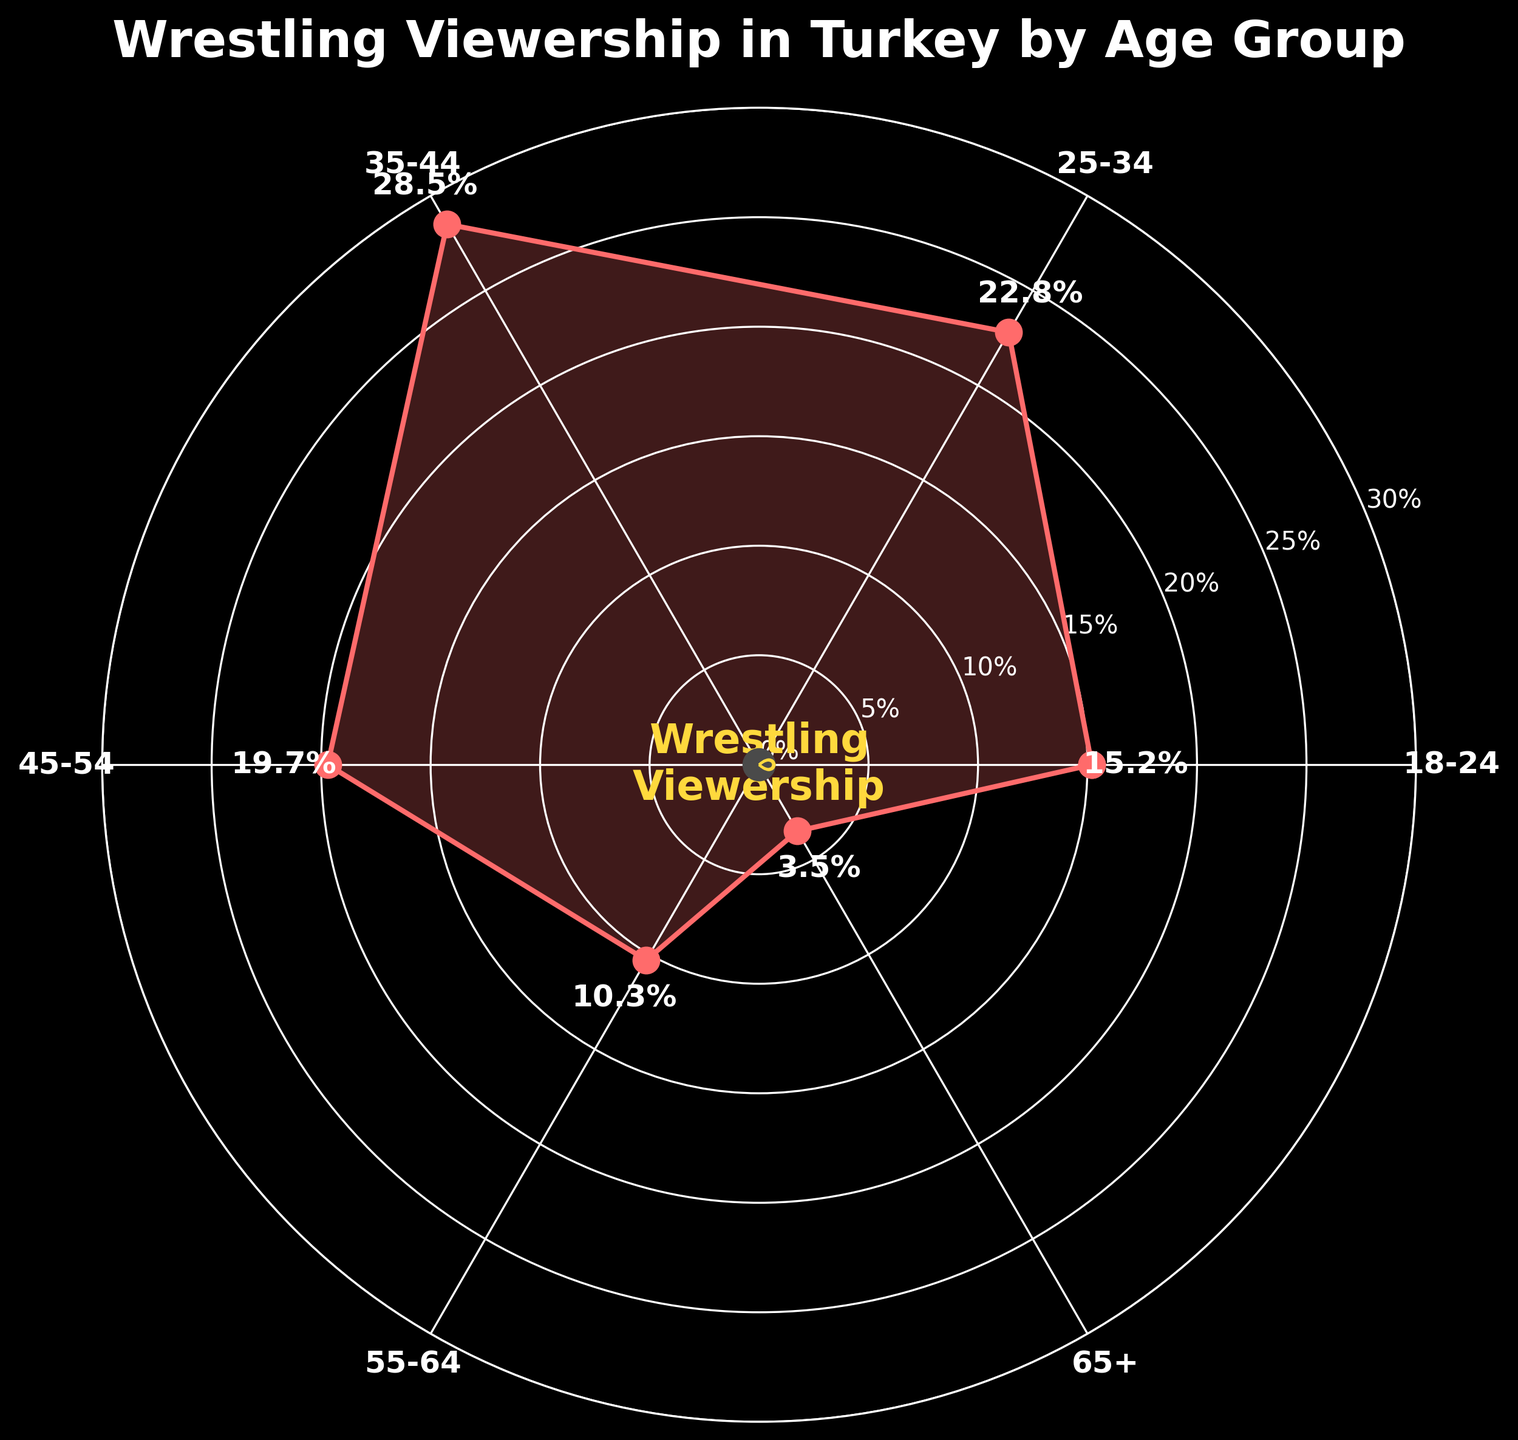What is the highest percentage of Turkish citizens who regularly watch wrestling? The highest percentage can be seen at the topmost data point on the plot, which aligns with the age group 35-44. The value indicated next to the point is 28.5%
Answer: 28.5% Which age group has the lowest percentage of viewers? The lowest percentage is at the smallest data point on the plot, which aligns with the age group 65+. The value indicated next to the point is 3.5%
Answer: 3.5% What is the percentage of viewers in the age group 18-24? To find the percentage of viewers in the age group 18-24, look at the position on the plot labeled 18-24. The value indicated next to this point is 15.2%
Answer: 15.2% Which age group has the second highest percentage of viewers? The second highest percentage can be identified by locating the second highest data point, which aligns with the age group 25-34. The value indicated next to this point is 22.8%
Answer: 22.8% Which category falls in the middle range of viewership percentages (10% to 29%)? The categories within this range can be observed as data points in the area going from just above 10% to just below 30%. These categories are 18-24, 25-34, 35-44, 45-54
Answer: 18-24, 25-34, 35-44, 45-54 Which age group has about twice the percentage of viewers compared to the 55-64 age group? The percentage for the 55-64 age group is 10.3%. Doubling this value gives approximately 20.6%. The closest age group percentage to this is 19.7%, which is for the age group 45-54
Answer: 45-54 What is the average percentage of viewers across all age groups? Sum the percentages (15.2 + 22.8 + 28.5 + 19.7 + 10.3 + 3.5) and divide by the number of age groups (6). Sum: 100. Divide: 100/6 = 16.67%
Answer: 16.67% How much greater is the percentage of viewers for the 35-44 age group compared to the 18-24 age group? Subtract the percentage of viewers in the 18-24 group (15.2%) from that in the 35-44 group (28.5%). Difference: 28.5 - 15.2 = 13.3%
Answer: 13.3% Which age groups have less than 20% viewership? The age groups with less than 20% viewership can be seen by locating the data points below the 20% mark. These age groups are 18-24, 45-54, 55-64, and 65+
Answer: 18-24, 45-54, 55-64, 65+ 